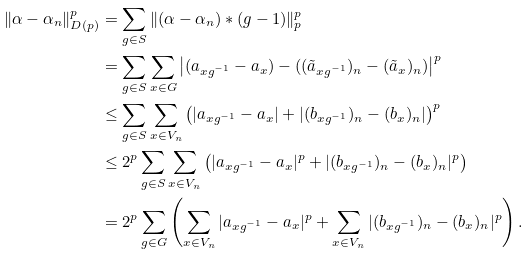<formula> <loc_0><loc_0><loc_500><loc_500>\| \alpha - \alpha _ { n } \| _ { D ( p ) } ^ { p } & = \sum _ { g \in S } \| ( \alpha - \alpha _ { n } ) \ast ( g - 1 ) \| _ { p } ^ { p } \\ & = \sum _ { g \in S } \sum _ { x \in G } \left | ( a _ { x g ^ { - 1 } } - a _ { x } ) - ( ( \tilde { a } _ { x g ^ { - 1 } } ) _ { n } - ( \tilde { a } _ { x } ) _ { n } ) \right | ^ { p } \\ & \leq \sum _ { g \in S } \sum _ { x \in V _ { n } } \left ( | a _ { x g ^ { - 1 } } - a _ { x } | + | ( b _ { x g ^ { - 1 } } ) _ { n } - ( b _ { x } ) _ { n } | \right ) ^ { p } \\ & \leq 2 ^ { p } \sum _ { g \in S } \sum _ { x \in V _ { n } } \left ( | a _ { x g ^ { - 1 } } - a _ { x } | ^ { p } + | ( b _ { x g ^ { - 1 } } ) _ { n } - ( b _ { x } ) _ { n } | ^ { p } \right ) \\ & = 2 ^ { p } \sum _ { g \in G } \left ( \sum _ { x \in V _ { n } } | a _ { x g ^ { - 1 } } - a _ { x } | ^ { p } + \sum _ { x \in V _ { n } } | ( b _ { x g ^ { - 1 } } ) _ { n } - ( b _ { x } ) _ { n } | ^ { p } \right ) .</formula> 